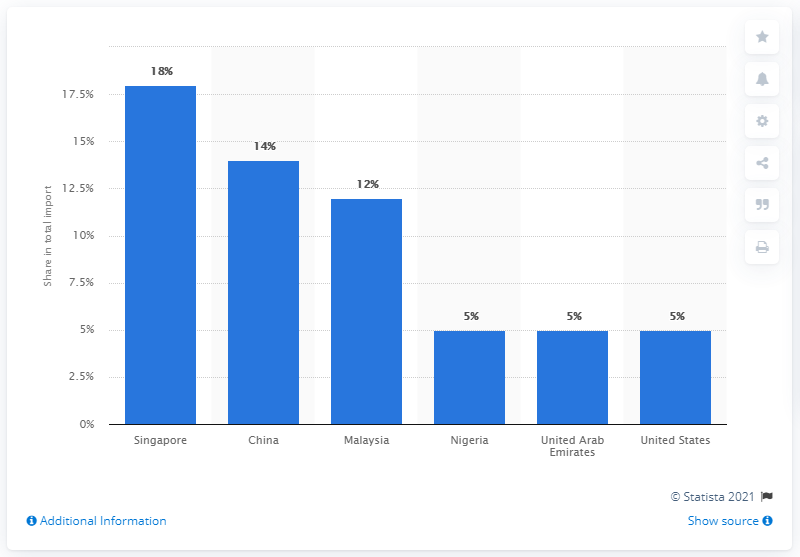Highlight a few significant elements in this photo. Brunei Darussalam's largest import partner in 2019 was Singapore. 